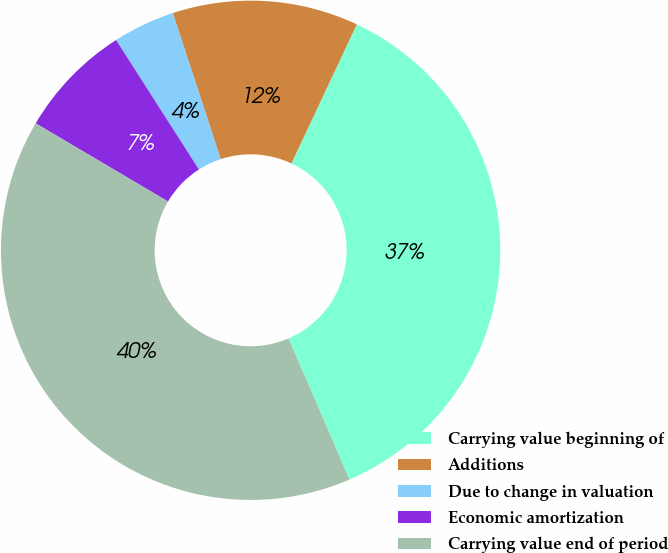Convert chart. <chart><loc_0><loc_0><loc_500><loc_500><pie_chart><fcel>Carrying value beginning of<fcel>Additions<fcel>Due to change in valuation<fcel>Economic amortization<fcel>Carrying value end of period<nl><fcel>36.53%<fcel>12.04%<fcel>4.01%<fcel>7.45%<fcel>39.96%<nl></chart> 